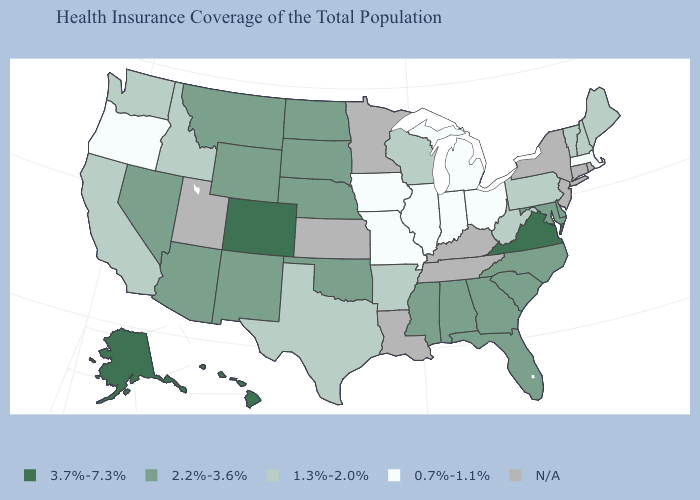Is the legend a continuous bar?
Write a very short answer. No. Does the map have missing data?
Quick response, please. Yes. Among the states that border Oklahoma , which have the lowest value?
Keep it brief. Missouri. What is the value of Kentucky?
Give a very brief answer. N/A. What is the value of Minnesota?
Be succinct. N/A. Among the states that border Wyoming , which have the highest value?
Give a very brief answer. Colorado. How many symbols are there in the legend?
Short answer required. 5. Name the states that have a value in the range N/A?
Be succinct. Connecticut, Kansas, Kentucky, Louisiana, Minnesota, New Jersey, New York, Rhode Island, Tennessee, Utah. Name the states that have a value in the range 2.2%-3.6%?
Short answer required. Alabama, Arizona, Delaware, Florida, Georgia, Maryland, Mississippi, Montana, Nebraska, Nevada, New Mexico, North Carolina, North Dakota, Oklahoma, South Carolina, South Dakota, Wyoming. Which states hav the highest value in the South?
Short answer required. Virginia. Name the states that have a value in the range N/A?
Write a very short answer. Connecticut, Kansas, Kentucky, Louisiana, Minnesota, New Jersey, New York, Rhode Island, Tennessee, Utah. What is the value of Nevada?
Answer briefly. 2.2%-3.6%. Does Pennsylvania have the lowest value in the USA?
Short answer required. No. Does South Carolina have the lowest value in the South?
Be succinct. No. 